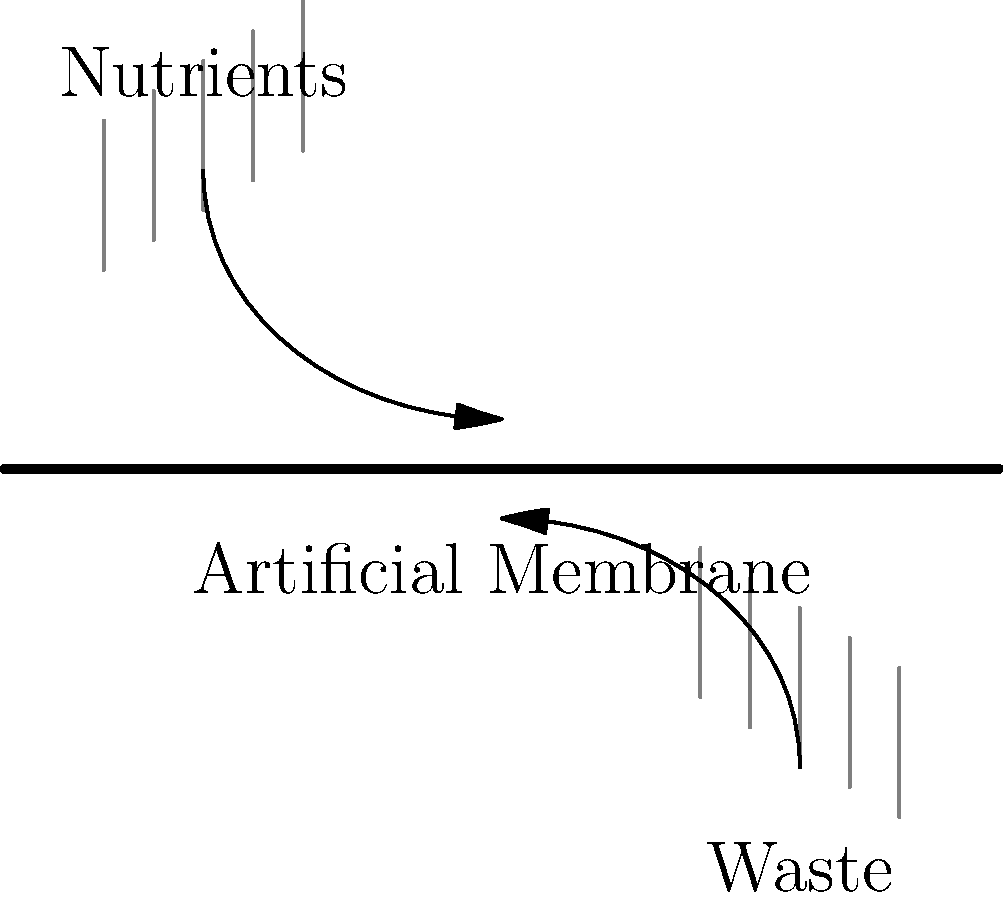In an artificial womb system, the diffusion rate of nutrients and waste products across the artificial membrane is crucial for fetal development. Given that the diffusion rate is proportional to the concentration gradient and inversely proportional to the membrane thickness, how would doubling the membrane thickness affect the diffusion rate, assuming all other factors remain constant? To understand how doubling the membrane thickness affects the diffusion rate, let's follow these steps:

1. Recall Fick's First Law of Diffusion:
   $$ J = -D \frac{dC}{dx} $$
   Where:
   $J$ is the diffusion flux (rate of transfer per unit area)
   $D$ is the diffusion coefficient
   $\frac{dC}{dx}$ is the concentration gradient

2. For a membrane of thickness $L$, we can approximate this as:
   $$ J = D \frac{\Delta C}{L} $$
   Where $\Delta C$ is the concentration difference across the membrane.

3. The diffusion rate is directly proportional to $J$. Let's call the initial diffusion rate $R_1$ and the initial thickness $L_1$:
   $$ R_1 \propto \frac{D \Delta C}{L_1} $$

4. Now, if we double the membrane thickness, the new thickness $L_2 = 2L_1$. Let's call the new diffusion rate $R_2$:
   $$ R_2 \propto \frac{D \Delta C}{L_2} = \frac{D \Delta C}{2L_1} $$

5. Comparing $R_2$ to $R_1$:
   $$ R_2 = \frac{1}{2} R_1 $$

6. This means that doubling the membrane thickness will halve the diffusion rate.
Answer: The diffusion rate will be halved. 